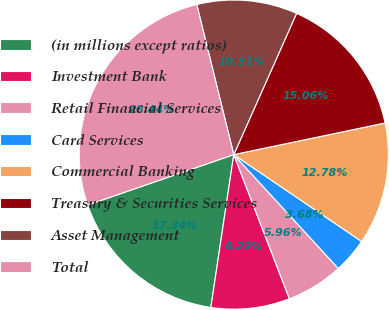<chart> <loc_0><loc_0><loc_500><loc_500><pie_chart><fcel>(in millions except ratios)<fcel>Investment Bank<fcel>Retail Financial Services<fcel>Card Services<fcel>Commercial Banking<fcel>Treasury & Securities Services<fcel>Asset Management<fcel>Total<nl><fcel>17.34%<fcel>8.23%<fcel>5.96%<fcel>3.68%<fcel>12.78%<fcel>15.06%<fcel>10.51%<fcel>26.44%<nl></chart> 